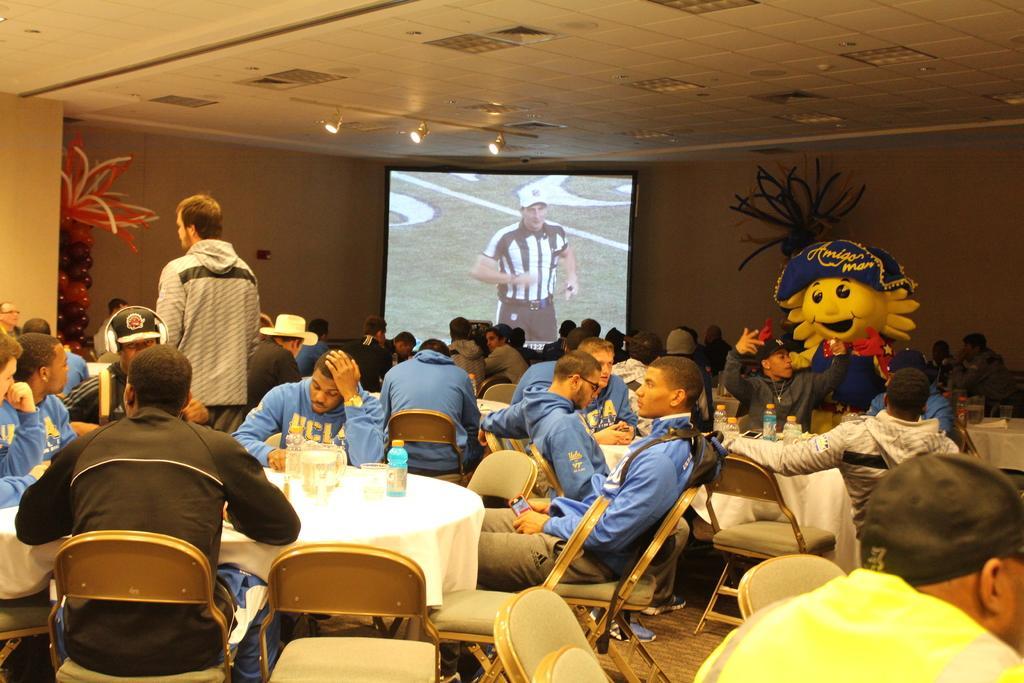Can you describe this image briefly? In the picture I can see these people are sitting on the chairs near the tables and this person is standing. In the background, I can see projector screen, decorative items, a person wearing different costume and ceiling lights. 